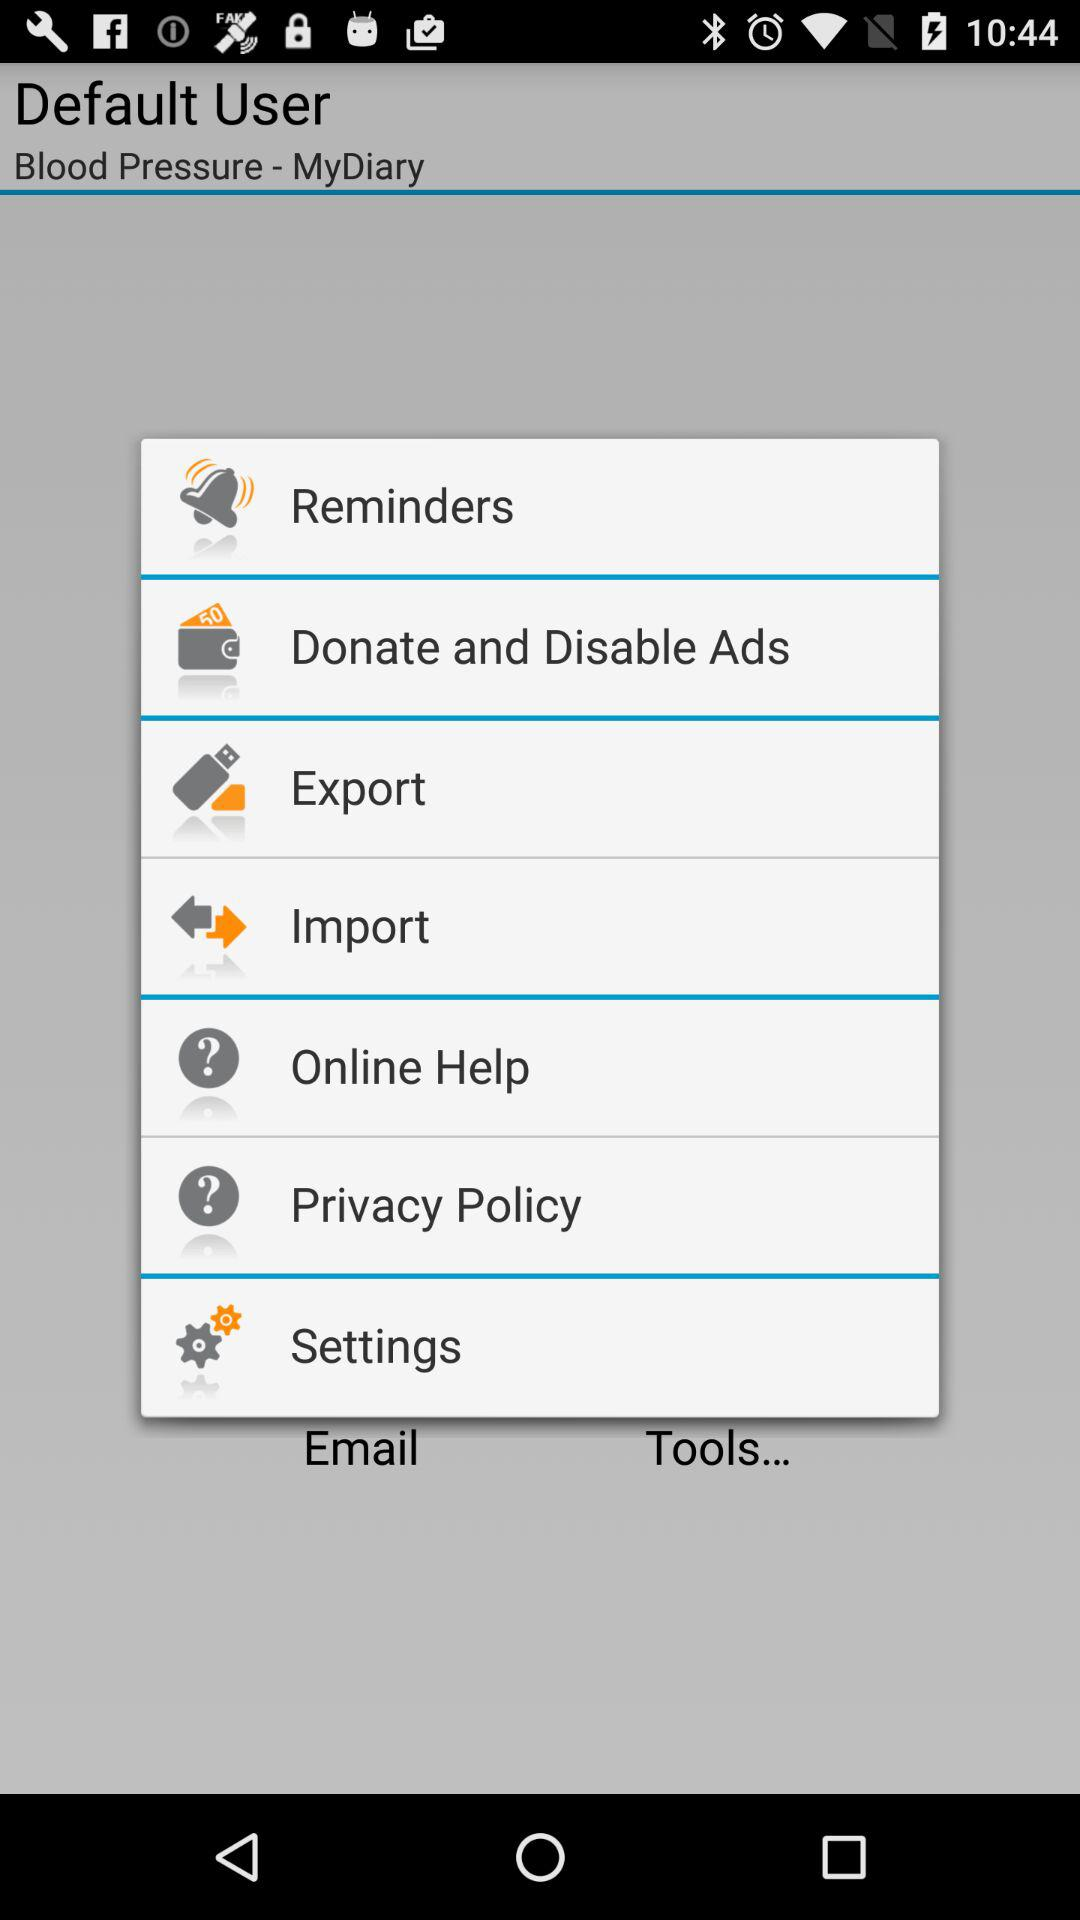What is the application name? The application name is "Blood Pressure - MyDiary". 